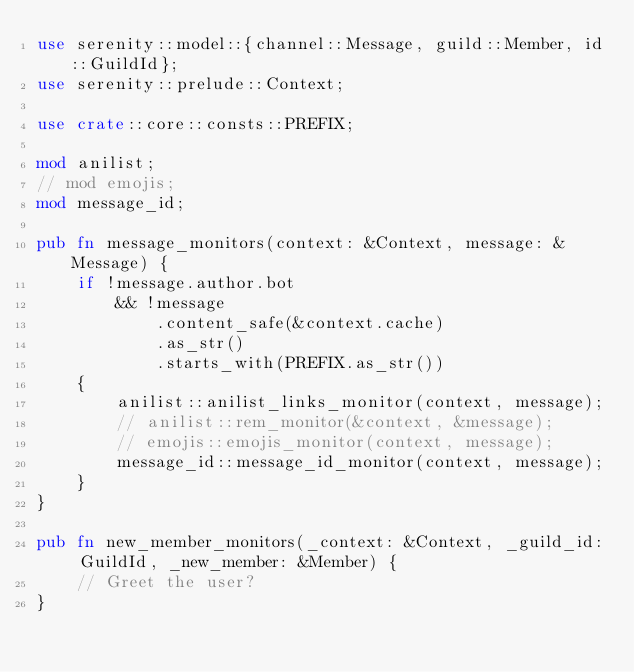<code> <loc_0><loc_0><loc_500><loc_500><_Rust_>use serenity::model::{channel::Message, guild::Member, id::GuildId};
use serenity::prelude::Context;

use crate::core::consts::PREFIX;

mod anilist;
// mod emojis;
mod message_id;

pub fn message_monitors(context: &Context, message: &Message) {
    if !message.author.bot
        && !message
            .content_safe(&context.cache)
            .as_str()
            .starts_with(PREFIX.as_str())
    {
        anilist::anilist_links_monitor(context, message);
        // anilist::rem_monitor(&context, &message);
        // emojis::emojis_monitor(context, message);
        message_id::message_id_monitor(context, message);
    }
}

pub fn new_member_monitors(_context: &Context, _guild_id: GuildId, _new_member: &Member) {
    // Greet the user?
}
</code> 